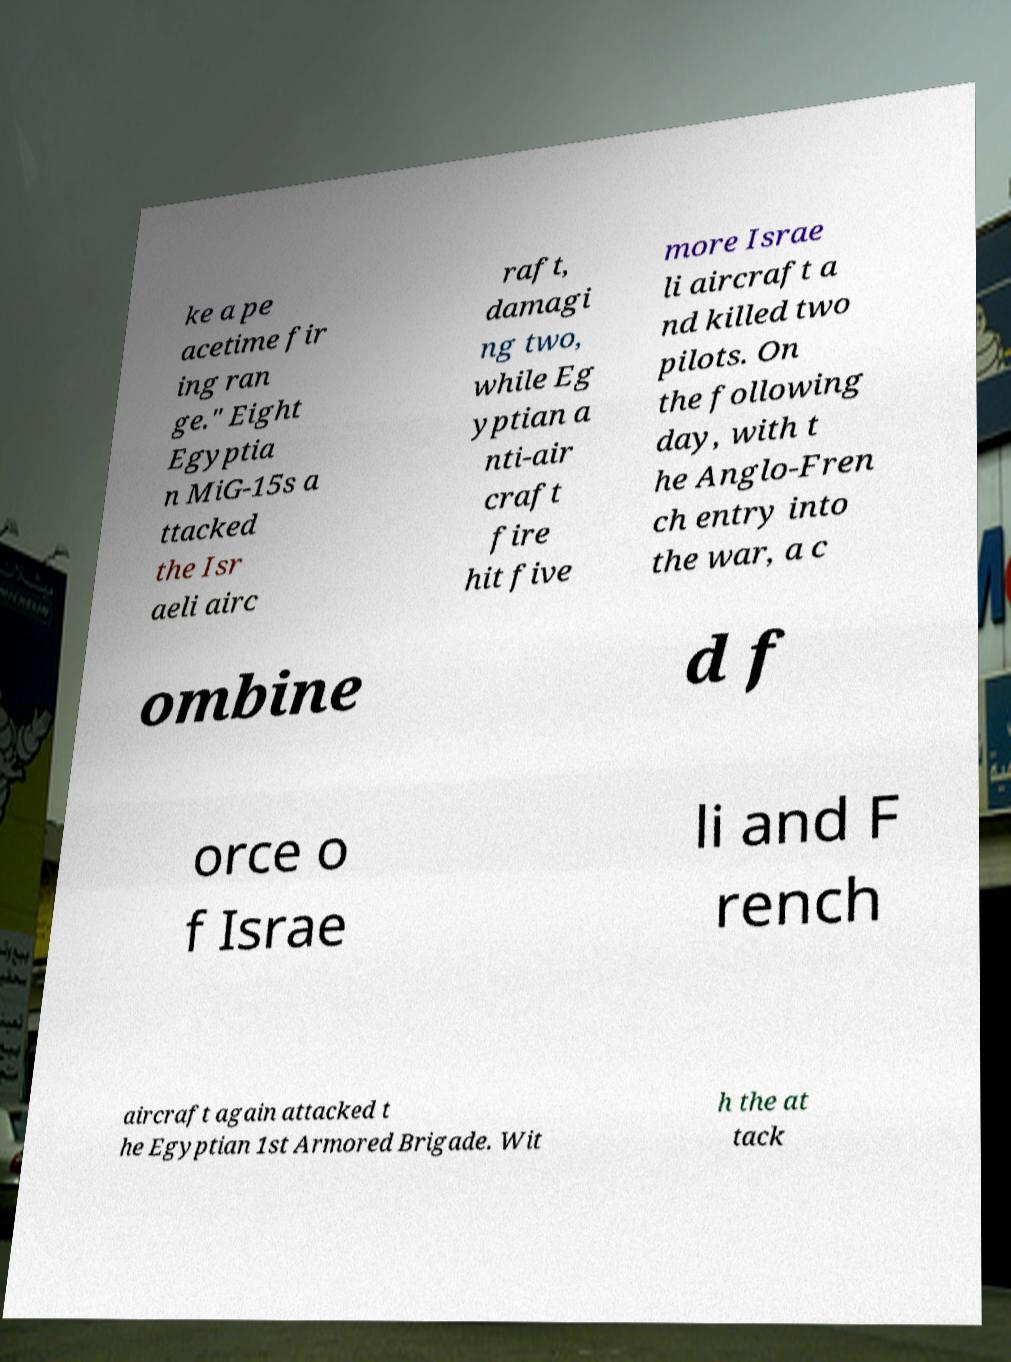Could you assist in decoding the text presented in this image and type it out clearly? ke a pe acetime fir ing ran ge." Eight Egyptia n MiG-15s a ttacked the Isr aeli airc raft, damagi ng two, while Eg yptian a nti-air craft fire hit five more Israe li aircraft a nd killed two pilots. On the following day, with t he Anglo-Fren ch entry into the war, a c ombine d f orce o f Israe li and F rench aircraft again attacked t he Egyptian 1st Armored Brigade. Wit h the at tack 